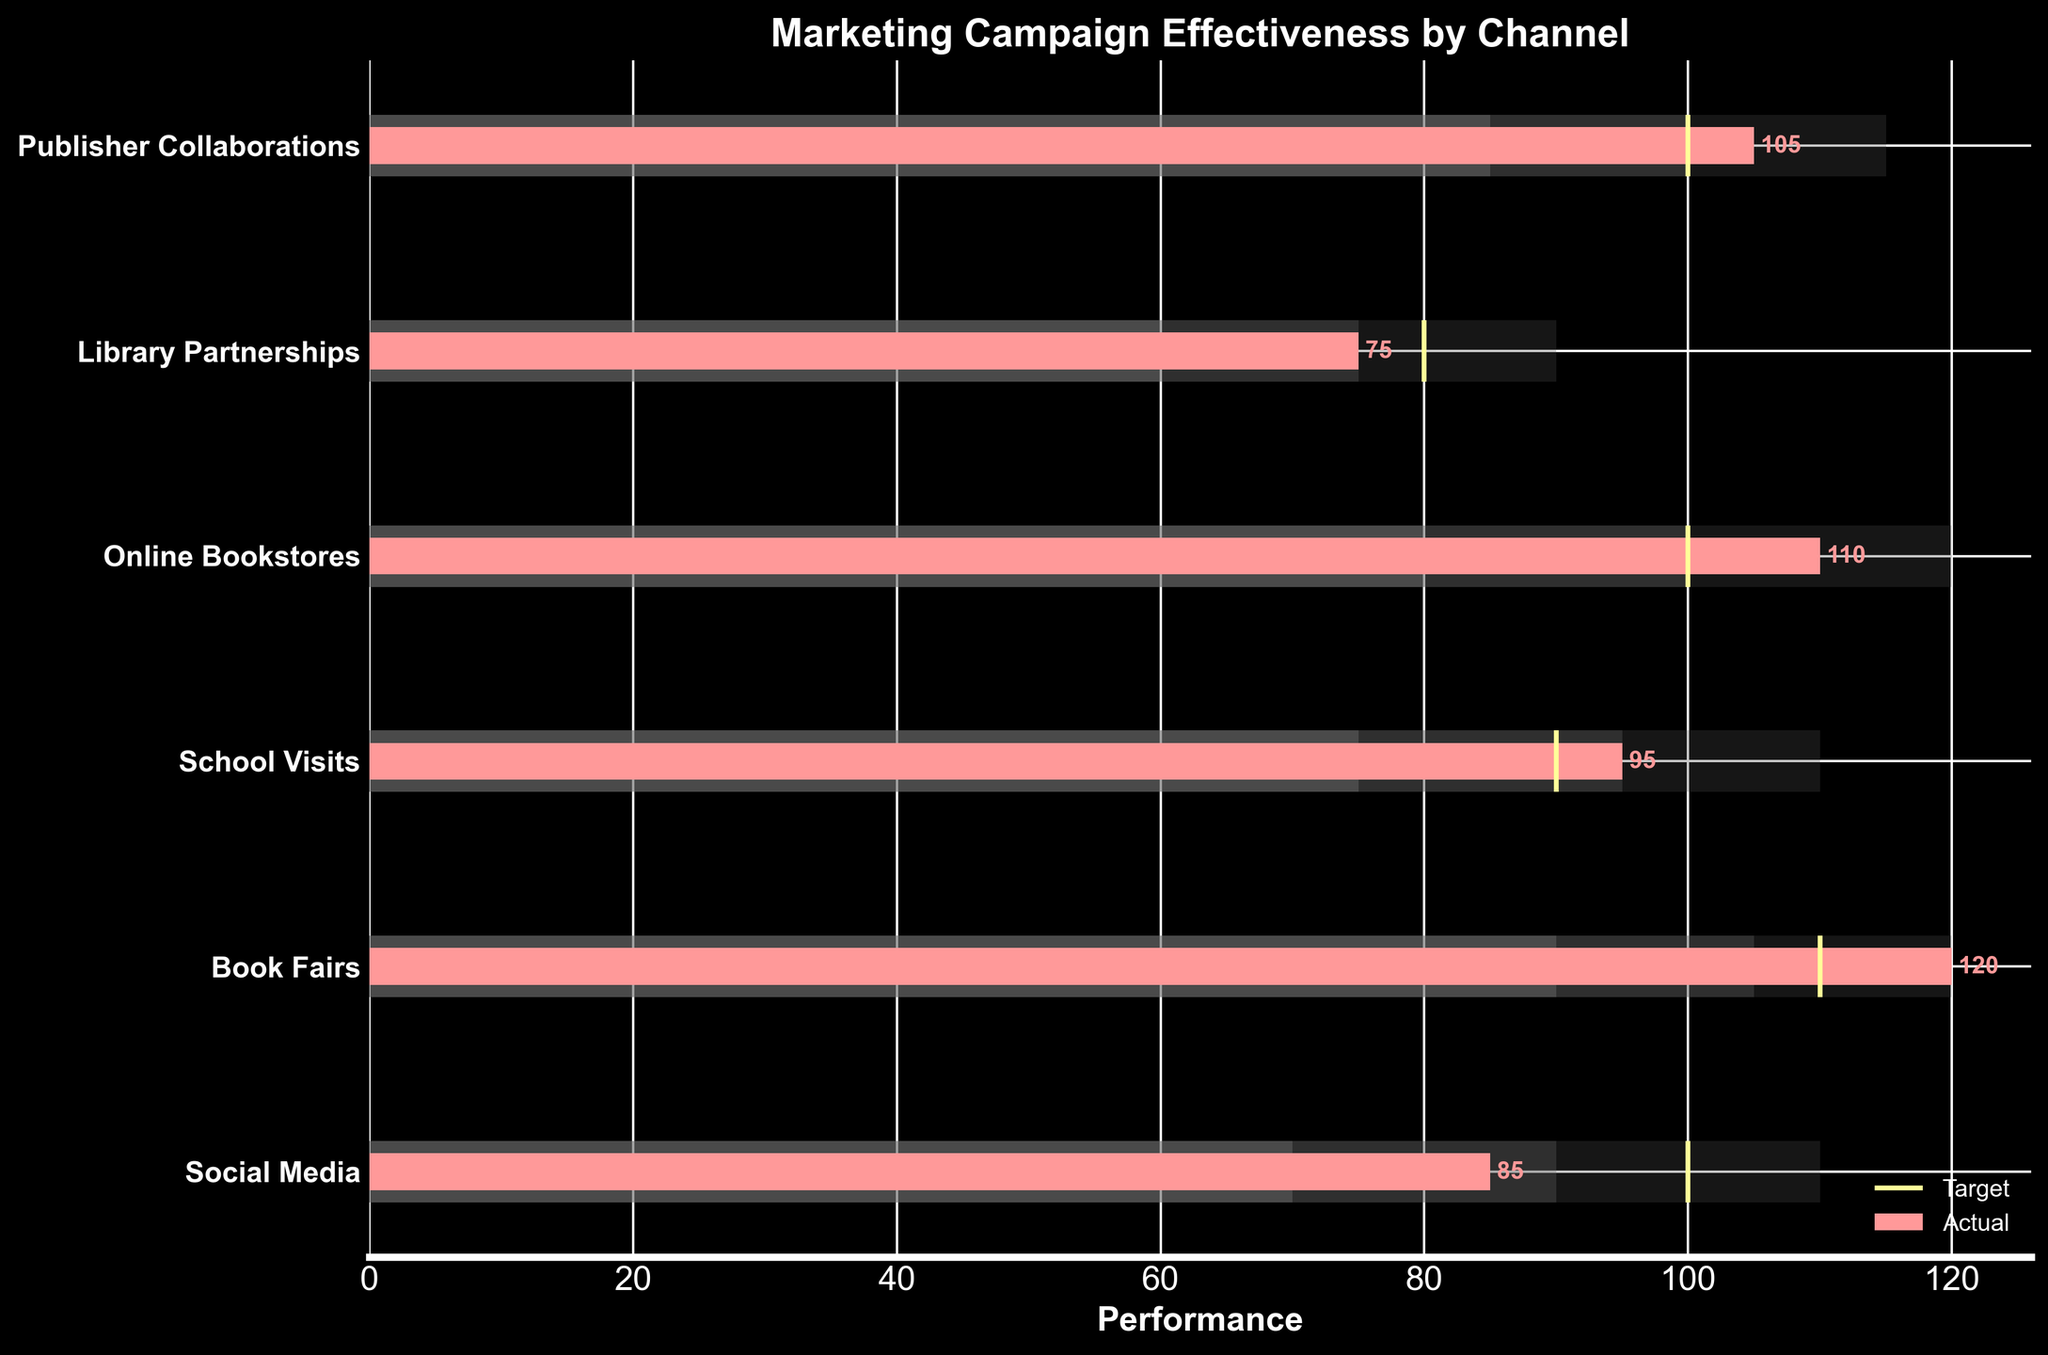What's the title of the chart? The title of the chart is located at the top and is prominently displayed in bold.
Answer: Marketing Campaign Effectiveness by Channel What's the performance of the Social Media channel? Look for the 'Social Media' row on the y-axis and check its corresponding value on the bar.
Answer: 85 Which channel has the highest actual performance? Compare the 'Actual' values for all the channels and identify the highest value.
Answer: Book Fairs How do the actual performances of School Visits and Library Partnerships compare? Locate the 'Actual' performances of both 'School Visits' and 'Library Partnerships' and compare them. School Visits: 95, Library Partnerships: 75
Answer: School Visits > Library Partnerships What is the average performance range for Online Bookstores? Identify the range corresponding to 'Average' for 'Online Bookstores'.
Answer: 80-100 Which channels met or exceeded their target performance? Compare the 'Actual' performance with the 'Target' performance for each channel and identify those that met or exceeded their target. Channels: Book Fairs (120 > 110), School Visits (95 > 90), Online Bookstores (110 = 100), Publisher Collaborations (105 > 100)
Answer: Book Fairs, School Visits, Online Bookstores, Publisher Collaborations Which channel has the most significant gap between actual performance and target? Calculate the difference between 'Actual' and 'Target' for each channel and identify the largest gap.
Answer: Social Media (15) What is the color coding for good performance? The 'Good' performance range has a specific color that can be identified from the horizontal bars.
Answer: Gray How many channels fall into the excellent performance range? Identify how many channels have actual performance values within their 'Excellent' range. 'Excellent' for: Book Fairs (90-120), School Visits (95-110), Online Bookstores (100-120), Publisher Collaborations (100-115) and their actual values.
Answer: 1 (Book Fairs) 